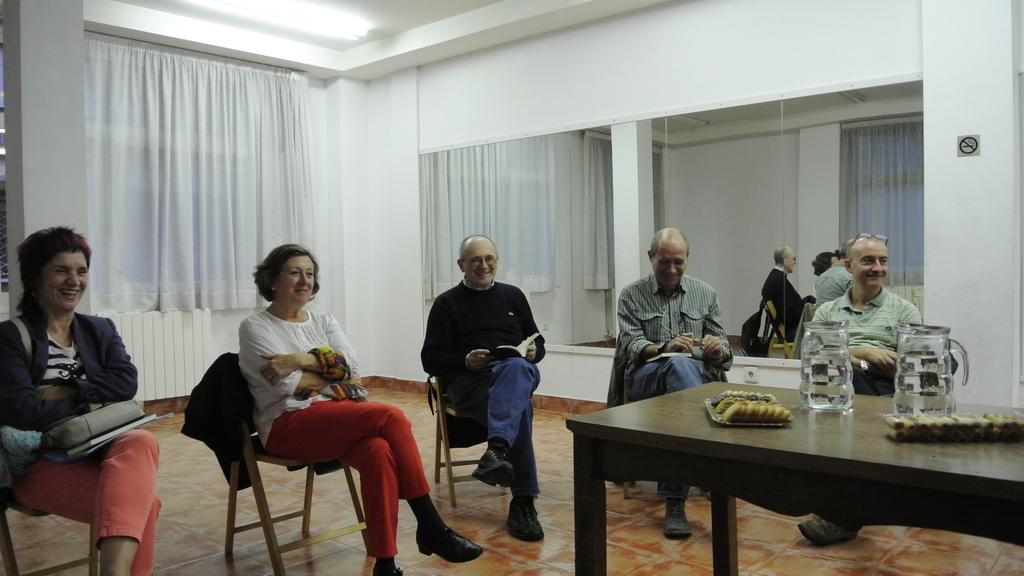How many people are in the image? There are five persons in the image. How many of them are men? Three of them are men. How many of them are women? Two of them are women. What are the persons doing in the image? The persons are sitting in chairs. What is present on the table in the image? There is a table in the image with some biscuits and two jugs placed on it. What is the name of the baby born during the gathering in the image? There is no indication of a baby being born or a gathering taking place in the image. 